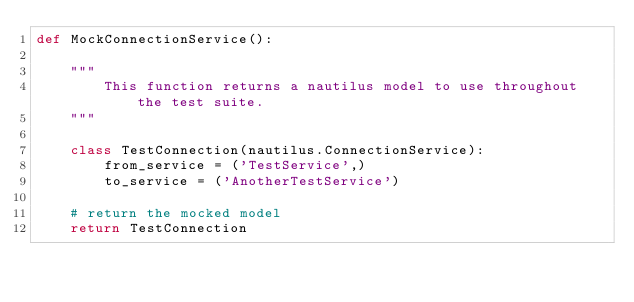Convert code to text. <code><loc_0><loc_0><loc_500><loc_500><_Python_>def MockConnectionService():

    """
        This function returns a nautilus model to use throughout the test suite.
    """

    class TestConnection(nautilus.ConnectionService):
        from_service = ('TestService',)
        to_service = ('AnotherTestService')

    # return the mocked model
    return TestConnection</code> 